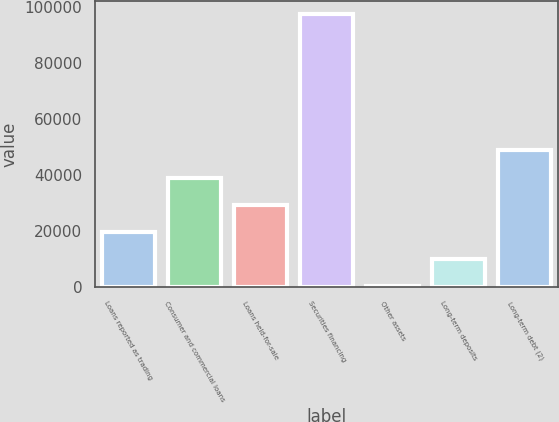Convert chart. <chart><loc_0><loc_0><loc_500><loc_500><bar_chart><fcel>Loans reported as trading<fcel>Consumer and commercial loans<fcel>Loans held-for-sale<fcel>Securities financing<fcel>Other assets<fcel>Long-term deposits<fcel>Long-term debt (2)<nl><fcel>19710.2<fcel>39167.4<fcel>29438.8<fcel>97539<fcel>253<fcel>9981.6<fcel>48896<nl></chart> 